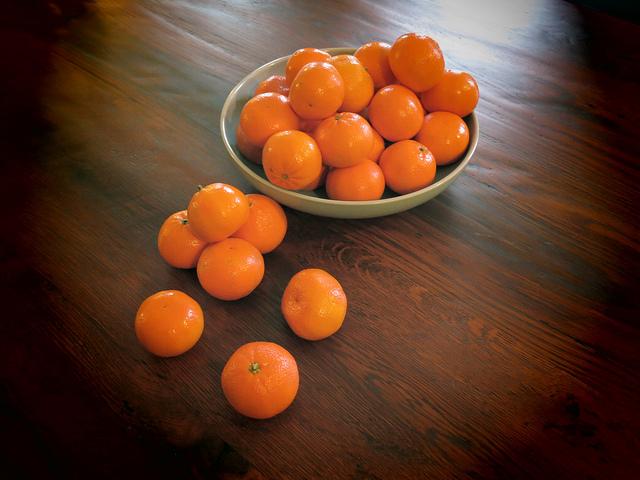Is the table wood?
Give a very brief answer. Yes. What color is the bowl?
Concise answer only. White. What food is this?
Keep it brief. Orange. Could the objects in the lower left hand corner be used to produce the substance in the top?
Quick response, please. Yes. What food group does this belong in?
Answer briefly. Fruit. 